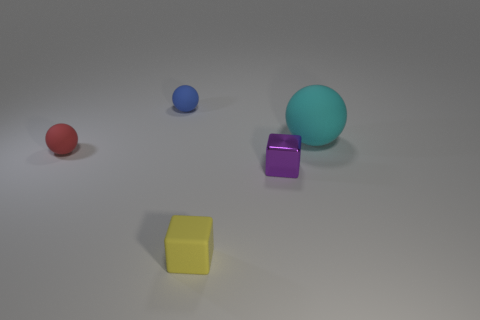Are there the same number of big matte things that are in front of the purple metal thing and objects that are behind the cyan thing?
Give a very brief answer. No. There is a small object behind the cyan ball; what is its shape?
Ensure brevity in your answer.  Sphere. What is the shape of the purple object that is the same size as the blue thing?
Offer a very short reply. Cube. What is the color of the tiny thing that is in front of the small thing right of the small yellow block on the left side of the cyan matte sphere?
Keep it short and to the point. Yellow. Do the small purple metal object and the big object have the same shape?
Offer a very short reply. No. Is the number of blocks that are in front of the tiny purple metal object the same as the number of matte balls?
Offer a very short reply. No. What number of other things are the same material as the yellow cube?
Your answer should be compact. 3. There is a ball that is right of the purple metallic block; is its size the same as the matte object in front of the red matte thing?
Your answer should be very brief. No. How many objects are spheres that are to the right of the small blue rubber object or small rubber things to the right of the blue matte thing?
Make the answer very short. 2. Is there any other thing that is the same shape as the tiny blue thing?
Keep it short and to the point. Yes. 